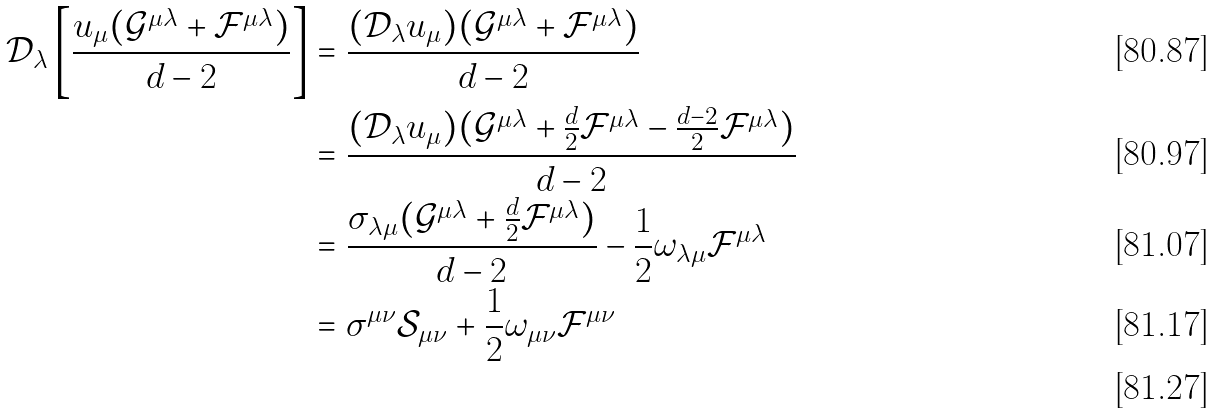<formula> <loc_0><loc_0><loc_500><loc_500>\mathcal { D } _ { \lambda } \left [ \frac { u _ { \mu } ( \mathcal { G } ^ { \mu \lambda } + \mathcal { F } ^ { \mu \lambda } ) } { d - 2 } \right ] & = \frac { ( \mathcal { D } _ { \lambda } u _ { \mu } ) ( \mathcal { G } ^ { \mu \lambda } + \mathcal { F } ^ { \mu \lambda } ) } { d - 2 } \\ & = \frac { ( \mathcal { D } _ { \lambda } u _ { \mu } ) ( \mathcal { G } ^ { \mu \lambda } + \frac { d } { 2 } \mathcal { F } ^ { \mu \lambda } - \frac { d - 2 } { 2 } \mathcal { F } ^ { \mu \lambda } ) } { d - 2 } \\ & = \frac { \sigma _ { \lambda \mu } ( \mathcal { G } ^ { \mu \lambda } + \frac { d } { 2 } \mathcal { F } ^ { \mu \lambda } ) } { d - 2 } - \frac { 1 } { 2 } \omega _ { \lambda \mu } \mathcal { F } ^ { \mu \lambda } \\ & = \sigma ^ { \mu \nu } \mathcal { S } _ { \mu \nu } + \frac { 1 } { 2 } \omega _ { \mu \nu } \mathcal { F } ^ { \mu \nu } \\</formula> 